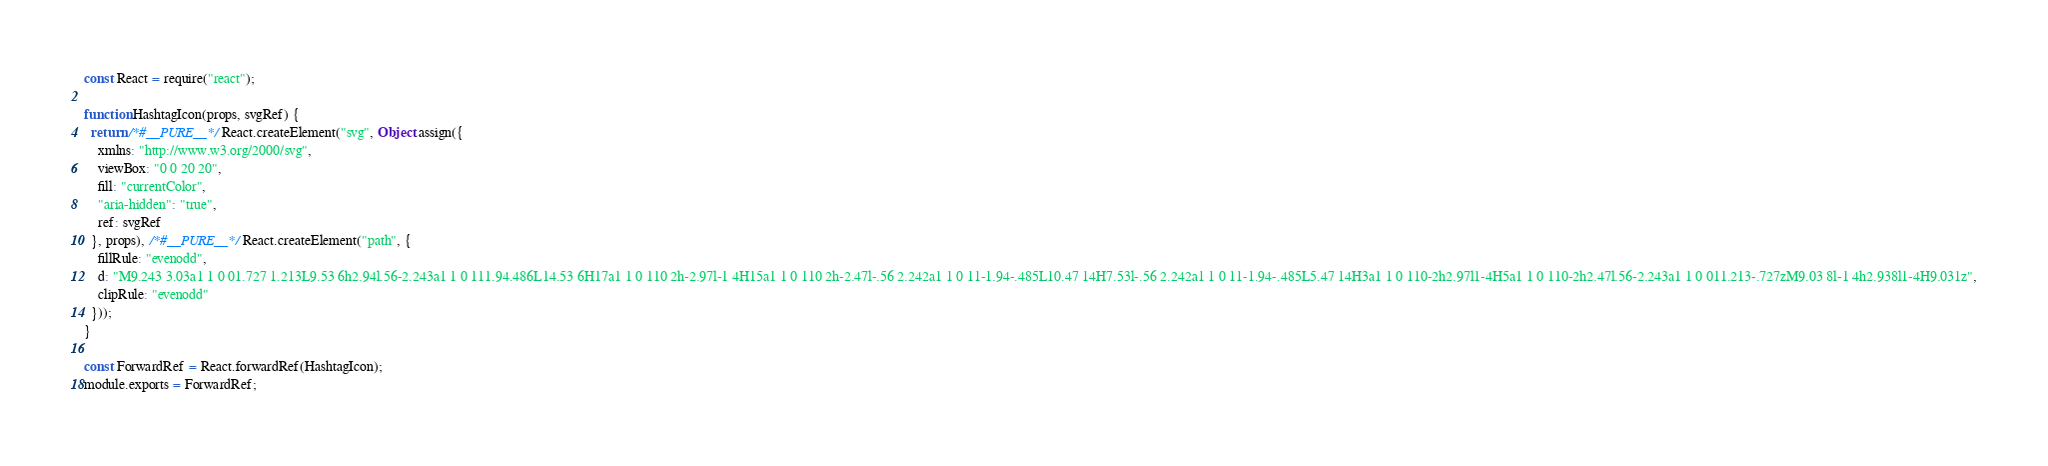Convert code to text. <code><loc_0><loc_0><loc_500><loc_500><_JavaScript_>const React = require("react");

function HashtagIcon(props, svgRef) {
  return /*#__PURE__*/React.createElement("svg", Object.assign({
    xmlns: "http://www.w3.org/2000/svg",
    viewBox: "0 0 20 20",
    fill: "currentColor",
    "aria-hidden": "true",
    ref: svgRef
  }, props), /*#__PURE__*/React.createElement("path", {
    fillRule: "evenodd",
    d: "M9.243 3.03a1 1 0 01.727 1.213L9.53 6h2.94l.56-2.243a1 1 0 111.94.486L14.53 6H17a1 1 0 110 2h-2.97l-1 4H15a1 1 0 110 2h-2.47l-.56 2.242a1 1 0 11-1.94-.485L10.47 14H7.53l-.56 2.242a1 1 0 11-1.94-.485L5.47 14H3a1 1 0 110-2h2.97l1-4H5a1 1 0 110-2h2.47l.56-2.243a1 1 0 011.213-.727zM9.03 8l-1 4h2.938l1-4H9.031z",
    clipRule: "evenodd"
  }));
}

const ForwardRef = React.forwardRef(HashtagIcon);
module.exports = ForwardRef;</code> 